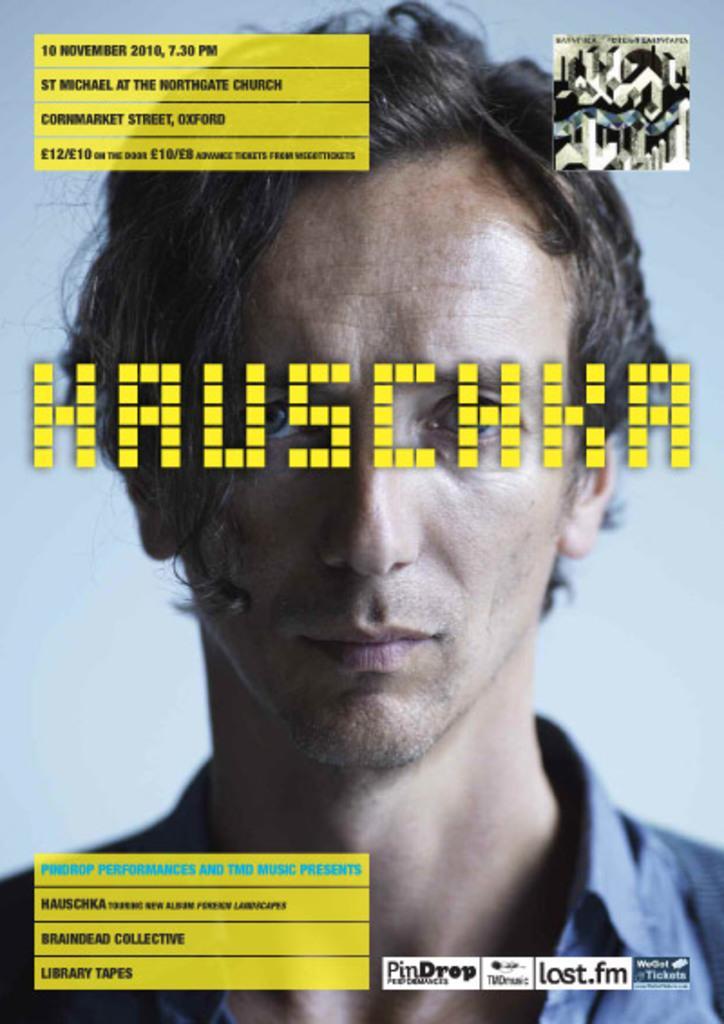Please provide a concise description of this image. There is a watermark in the middle of this image, at the top of this image and at the bottom of this image as well. We can see a person in the background. 